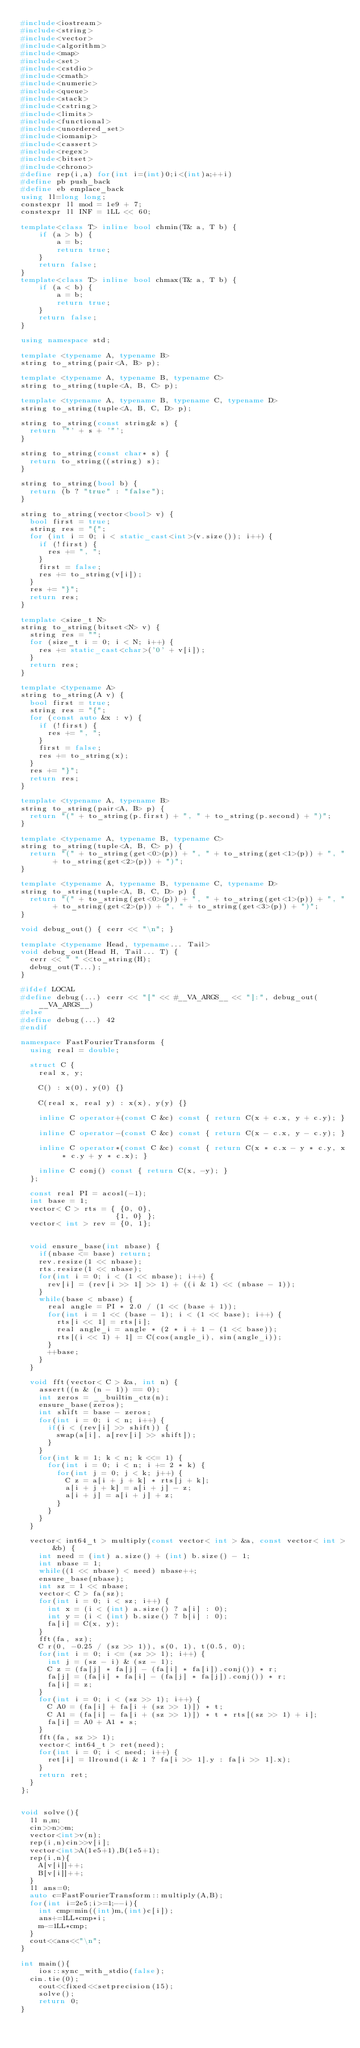Convert code to text. <code><loc_0><loc_0><loc_500><loc_500><_C++_>#include<iostream>
#include<string>
#include<vector>
#include<algorithm>
#include<map>
#include<set>
#include<cstdio>
#include<cmath>
#include<numeric>
#include<queue>
#include<stack>
#include<cstring>
#include<limits>
#include<functional>
#include<unordered_set>
#include<iomanip>
#include<cassert>
#include<regex>
#include<bitset>
#include<chrono>
#define rep(i,a) for(int i=(int)0;i<(int)a;++i)
#define pb push_back
#define eb emplace_back
using ll=long long;
constexpr ll mod = 1e9 + 7;
constexpr ll INF = 1LL << 60;
 
template<class T> inline bool chmin(T& a, T b) {
    if (a > b) {
        a = b;
        return true;
    }
    return false;
}
template<class T> inline bool chmax(T& a, T b) {
    if (a < b) {
        a = b;
        return true;
    }
    return false;
}
 
using namespace std;
 
template <typename A, typename B>
string to_string(pair<A, B> p);
 
template <typename A, typename B, typename C>
string to_string(tuple<A, B, C> p);
 
template <typename A, typename B, typename C, typename D>
string to_string(tuple<A, B, C, D> p);
 
string to_string(const string& s) {
  return '"' + s + '"';
}
 
string to_string(const char* s) {
  return to_string((string) s);
}
 
string to_string(bool b) {
  return (b ? "true" : "false");
}
 
string to_string(vector<bool> v) {
  bool first = true;
  string res = "{";
  for (int i = 0; i < static_cast<int>(v.size()); i++) {
    if (!first) {
      res += ", ";
    }
    first = false;
    res += to_string(v[i]);
  }
  res += "}";
  return res;
}
 
template <size_t N>
string to_string(bitset<N> v) {
  string res = "";
  for (size_t i = 0; i < N; i++) {
    res += static_cast<char>('0' + v[i]);
  }
  return res;
}
 
template <typename A>
string to_string(A v) {
  bool first = true;
  string res = "{";
  for (const auto &x : v) {
    if (!first) {
      res += ", ";
    }
    first = false;
    res += to_string(x);
  }
  res += "}";
  return res;
}
 
template <typename A, typename B>
string to_string(pair<A, B> p) {
  return "(" + to_string(p.first) + ", " + to_string(p.second) + ")";
}
 
template <typename A, typename B, typename C>
string to_string(tuple<A, B, C> p) {
  return "(" + to_string(get<0>(p)) + ", " + to_string(get<1>(p)) + ", " + to_string(get<2>(p)) + ")";
}
 
template <typename A, typename B, typename C, typename D>
string to_string(tuple<A, B, C, D> p) {
  return "(" + to_string(get<0>(p)) + ", " + to_string(get<1>(p)) + ", " + to_string(get<2>(p)) + ", " + to_string(get<3>(p)) + ")";
}
 
void debug_out() { cerr << "\n"; }
 
template <typename Head, typename... Tail>
void debug_out(Head H, Tail... T) {
  cerr << " " <<to_string(H);
  debug_out(T...);
}

#ifdef LOCAL
#define debug(...) cerr << "[" << #__VA_ARGS__ << "]:", debug_out(__VA_ARGS__)
#else
#define debug(...) 42
#endif

namespace FastFourierTransform {
  using real = double;

  struct C {
    real x, y;

    C() : x(0), y(0) {}

    C(real x, real y) : x(x), y(y) {}

    inline C operator+(const C &c) const { return C(x + c.x, y + c.y); }

    inline C operator-(const C &c) const { return C(x - c.x, y - c.y); }

    inline C operator*(const C &c) const { return C(x * c.x - y * c.y, x * c.y + y * c.x); }

    inline C conj() const { return C(x, -y); }
  };

  const real PI = acosl(-1);
  int base = 1;
  vector< C > rts = { {0, 0},
                     {1, 0} };
  vector< int > rev = {0, 1};


  void ensure_base(int nbase) {
    if(nbase <= base) return;
    rev.resize(1 << nbase);
    rts.resize(1 << nbase);
    for(int i = 0; i < (1 << nbase); i++) {
      rev[i] = (rev[i >> 1] >> 1) + ((i & 1) << (nbase - 1));
    }
    while(base < nbase) {
      real angle = PI * 2.0 / (1 << (base + 1));
      for(int i = 1 << (base - 1); i < (1 << base); i++) {
        rts[i << 1] = rts[i];
        real angle_i = angle * (2 * i + 1 - (1 << base));
        rts[(i << 1) + 1] = C(cos(angle_i), sin(angle_i));
      }
      ++base;
    }
  }

  void fft(vector< C > &a, int n) {
    assert((n & (n - 1)) == 0);
    int zeros = __builtin_ctz(n);
    ensure_base(zeros);
    int shift = base - zeros;
    for(int i = 0; i < n; i++) {
      if(i < (rev[i] >> shift)) {
        swap(a[i], a[rev[i] >> shift]);
      }
    }
    for(int k = 1; k < n; k <<= 1) {
      for(int i = 0; i < n; i += 2 * k) {
        for(int j = 0; j < k; j++) {
          C z = a[i + j + k] * rts[j + k];
          a[i + j + k] = a[i + j] - z;
          a[i + j] = a[i + j] + z;
        }
      }
    }
  }

  vector< int64_t > multiply(const vector< int > &a, const vector< int > &b) {
    int need = (int) a.size() + (int) b.size() - 1;
    int nbase = 1;
    while((1 << nbase) < need) nbase++;
    ensure_base(nbase);
    int sz = 1 << nbase;
    vector< C > fa(sz);
    for(int i = 0; i < sz; i++) {
      int x = (i < (int) a.size() ? a[i] : 0);
      int y = (i < (int) b.size() ? b[i] : 0);
      fa[i] = C(x, y);
    }
    fft(fa, sz);
    C r(0, -0.25 / (sz >> 1)), s(0, 1), t(0.5, 0);
    for(int i = 0; i <= (sz >> 1); i++) {
      int j = (sz - i) & (sz - 1);
      C z = (fa[j] * fa[j] - (fa[i] * fa[i]).conj()) * r;
      fa[j] = (fa[i] * fa[i] - (fa[j] * fa[j]).conj()) * r;
      fa[i] = z;
    }
    for(int i = 0; i < (sz >> 1); i++) {
      C A0 = (fa[i] + fa[i + (sz >> 1)]) * t;
      C A1 = (fa[i] - fa[i + (sz >> 1)]) * t * rts[(sz >> 1) + i];
      fa[i] = A0 + A1 * s;
    }
    fft(fa, sz >> 1);
    vector< int64_t > ret(need);
    for(int i = 0; i < need; i++) {
      ret[i] = llround(i & 1 ? fa[i >> 1].y : fa[i >> 1].x);
    }
    return ret;
  }
};


void solve(){
  ll n,m;
  cin>>n>>m;
  vector<int>v(n);
  rep(i,n)cin>>v[i];
  vector<int>A(1e5+1),B(1e5+1);
  rep(i,n){
    A[v[i]]++;
    B[v[i]]++;
  }
  ll ans=0;
  auto c=FastFourierTransform::multiply(A,B);
  for(int i=2e5;i>=1;--i){
    int cmp=min((int)m,(int)c[i]);
    ans+=1LL*cmp*i;
    m-=1LL*cmp;
  }
  cout<<ans<<"\n";
}
 
int main(){
	ios::sync_with_stdio(false);
  cin.tie(0);
	cout<<fixed<<setprecision(15);
	solve();
	return 0;
}
</code> 